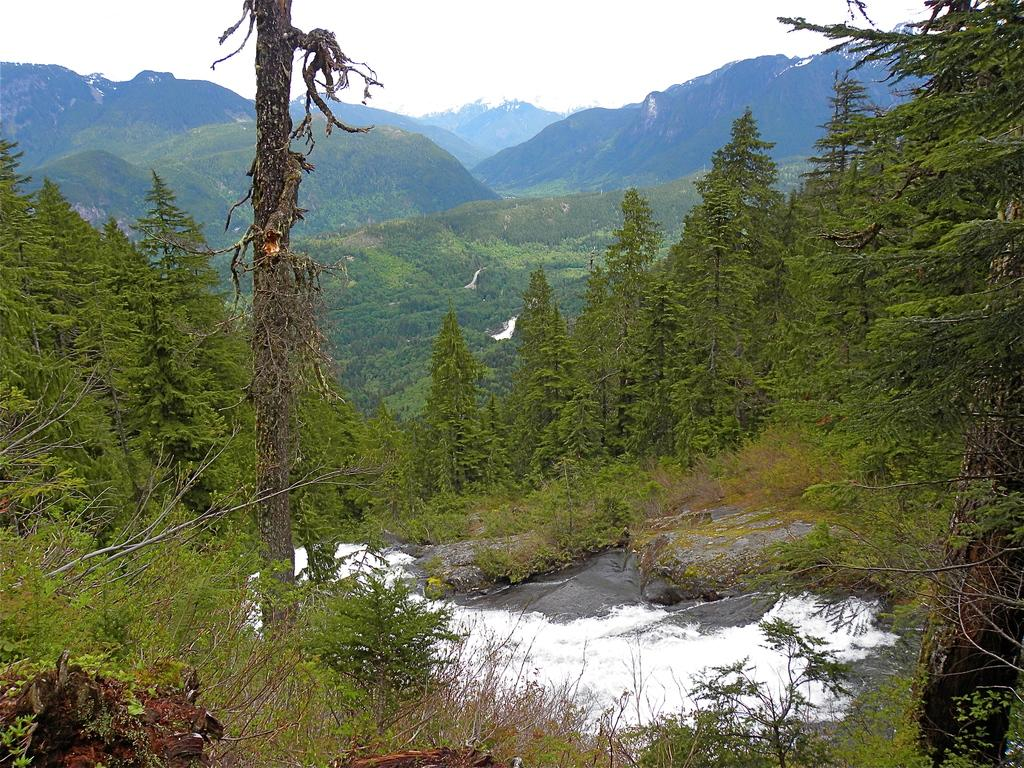What is the primary element present in the image? There is water in the image. What type of vegetation can be seen in the image? There are plants and trees in the image. What geographical feature is visible in the image? There are hills visible in the image. What part of the natural environment is visible in the image? The sky is visible in the image. What color are the objects in the image? There are white colored objects in the image. What verse can be heard recited by the goat in the image? There is no goat present in the image, and therefore no verse can be heard. What type of nose can be seen on the plants in the image? Plants do not have noses, so this detail cannot be observed in the image. 